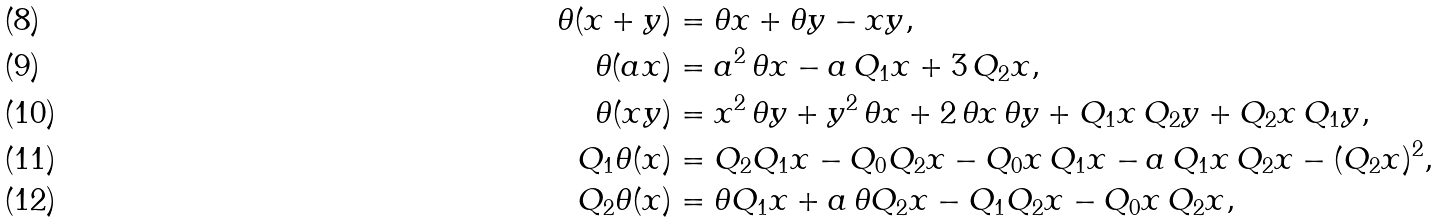Convert formula to latex. <formula><loc_0><loc_0><loc_500><loc_500>\theta ( x + y ) & = \theta x + \theta y - x y , \\ \theta ( a x ) & = a ^ { 2 } \, \theta x - a \, Q _ { 1 } x + 3 \, Q _ { 2 } x , \\ \theta ( x y ) & = x ^ { 2 } \, \theta y + y ^ { 2 } \, \theta x + 2 \, \theta x \, \theta y + Q _ { 1 } x \, Q _ { 2 } y + Q _ { 2 } x \, Q _ { 1 } y , \\ Q _ { 1 } \theta ( x ) & = Q _ { 2 } Q _ { 1 } x - Q _ { 0 } Q _ { 2 } x - Q _ { 0 } x \, Q _ { 1 } x - a \, Q _ { 1 } x \, Q _ { 2 } x - ( Q _ { 2 } x ) ^ { 2 } , \\ Q _ { 2 } \theta ( x ) & = \theta Q _ { 1 } x + a \, \theta Q _ { 2 } x - Q _ { 1 } Q _ { 2 } x - Q _ { 0 } x \, Q _ { 2 } x ,</formula> 